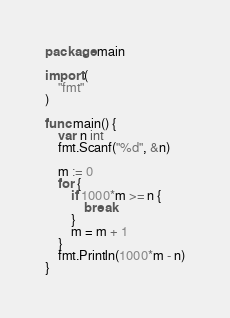Convert code to text. <code><loc_0><loc_0><loc_500><loc_500><_Go_>package main

import (
	"fmt"
)

func main() {
	var n int
	fmt.Scanf("%d", &n)

	m := 0
	for {
		if 1000*m >= n {
			break
		}
		m = m + 1
	}
	fmt.Println(1000*m - n)
}
</code> 